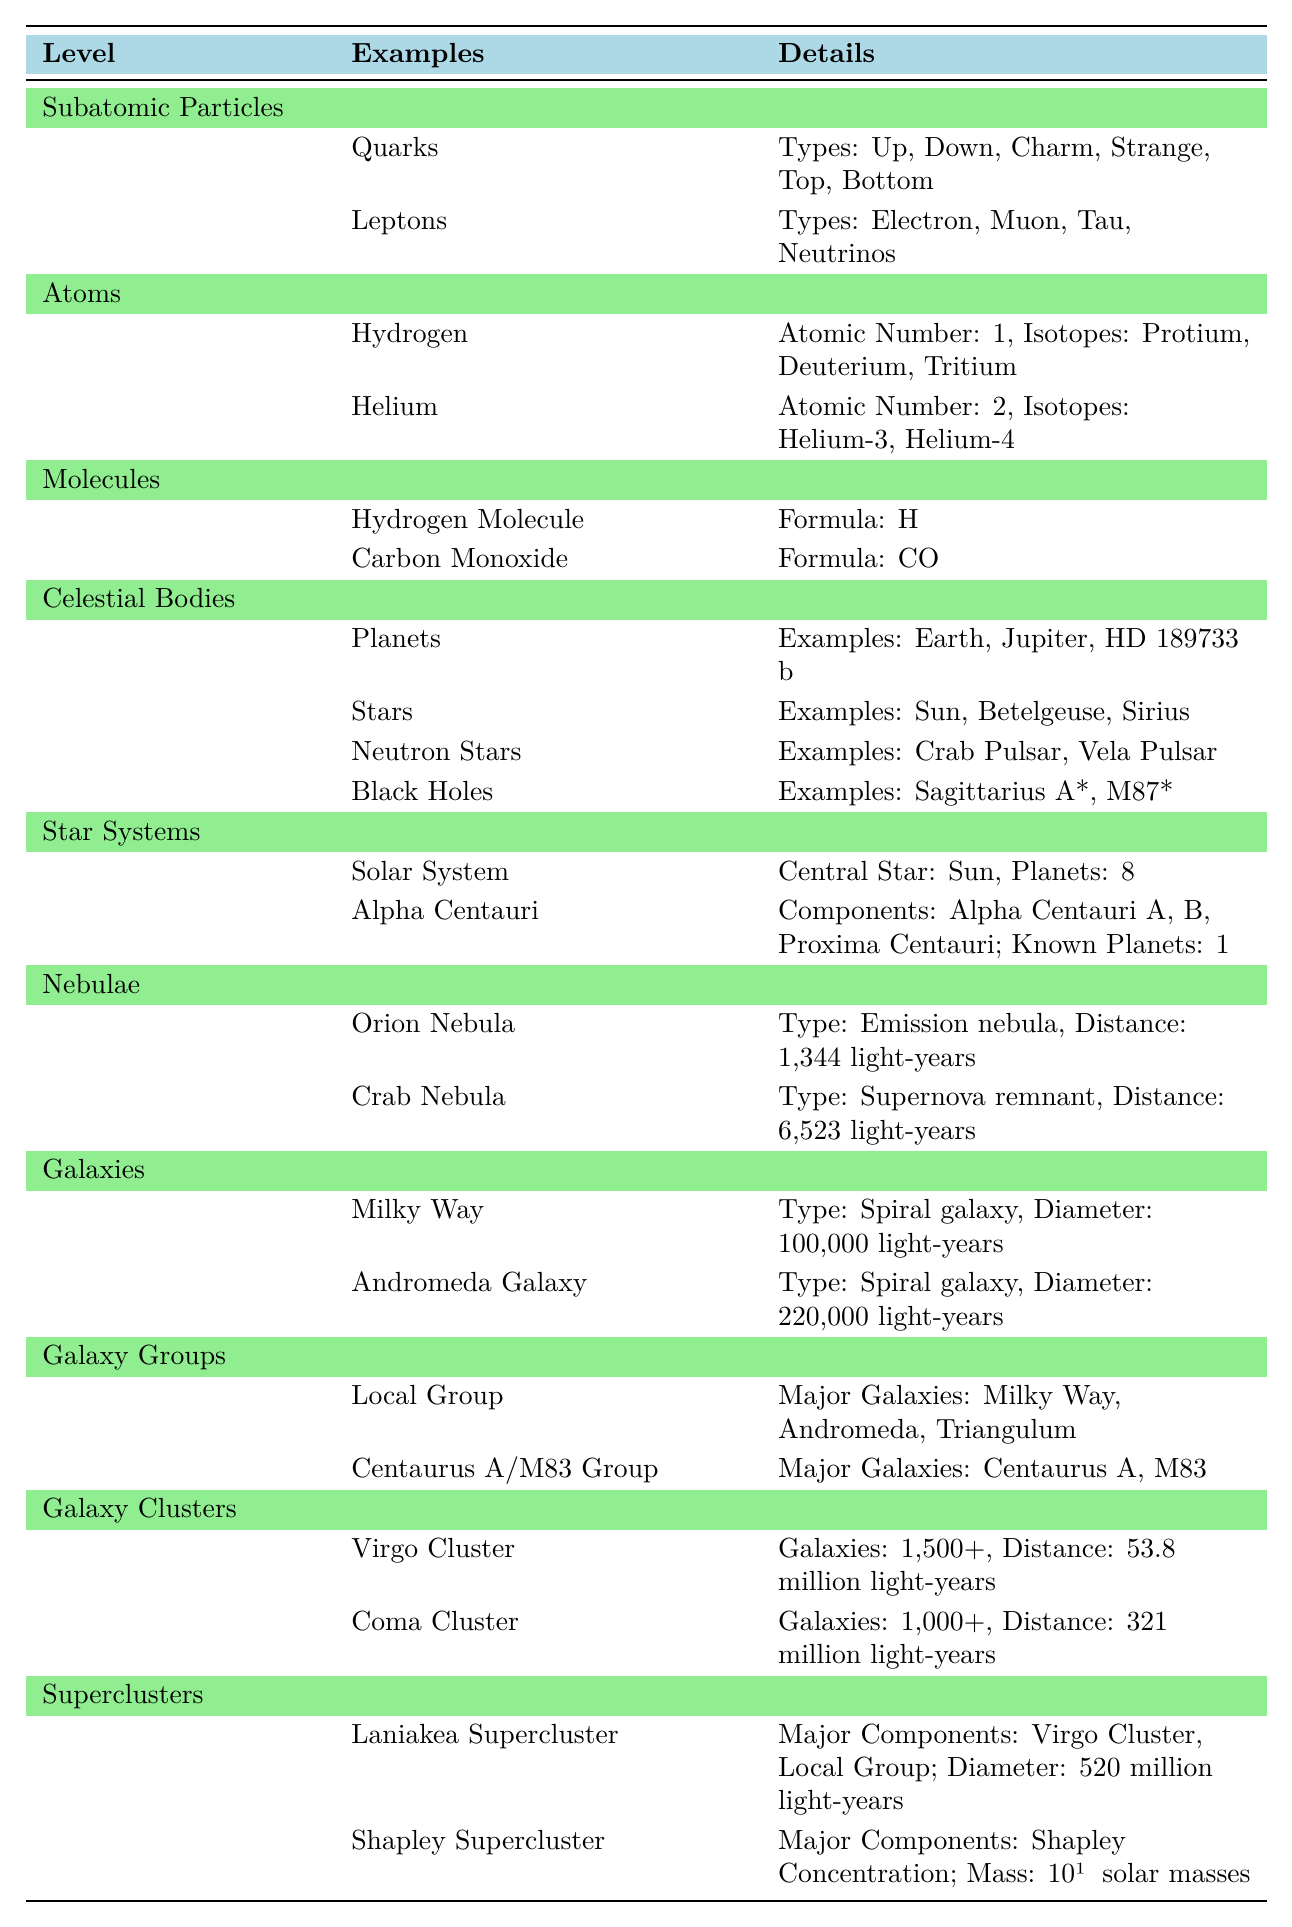What are the types of quarks listed in the table? The table provides information under the "Subatomic Particles" section, specifically mentioning quarks. It lists six types: Up, Down, Charm, Strange, Top, and Bottom.
Answer: Up, Down, Charm, Strange, Top, Bottom How many planets are in the Solar System according to the table? Under the "Star Systems" section, the Solar System is mentioned with the detail indicating it has 8 planets.
Answer: 8 Which nebula is classified as a supernova remnant? The table lists two nebulae under the "Nebulae" section. The Crab Nebula is specifically categorized as a "Supernova remnant."
Answer: Crab Nebula What is the diameter of the Andromeda Galaxy? In the "Galaxies" section, the Andromeda Galaxy is described and its diameter is specified as 220,000 light-years.
Answer: 220,000 light-years How many major galaxies are listed for the Local Group? The "Galaxy Groups" section states that the Local Group contains three major galaxies: Milky Way, Andromeda, and Triangulum.
Answer: 3 Is the Milky Way classified as a spiral galaxy? The table indicates that the Milky Way is mentioned under the "Galaxies" section and is classified as a spiral galaxy, confirming the statement.
Answer: Yes What is the total mass of Shapley Supercluster, according to the table? The table specifies the Shapley Supercluster's mass as 10¹⁶ solar masses in the "Superclusters" section.
Answer: 10¹⁶ solar masses Which type of nebula is the Orion Nebula categorized under? Within the "Nebulae" section, the Orion Nebula is classified as an "Emission nebula," thus providing the answer directly.
Answer: Emission nebula What is the distance to the Crab Nebula? The distance to the Crab Nebula is specified in the "Nebulae" section of the table as 6,523 light-years.
Answer: 6,523 light-years Which has a greater diameter, the Milky Way or the Laniakea Supercluster? The Milky Way's diameter is 100,000 light-years, and the Laniakea Supercluster's diameter is listed as 520 million light-years. Comparing both values, the Laniakea Supercluster has a far greater diameter than the Milky Way.
Answer: Laniakea Supercluster How many planets are indicated for the Alpha Centauri system? The table provides the information under the "Star Systems" section, mentioning that there is 1 known planet in the Alpha Centauri system.
Answer: 1 Which galaxy group includes the Centaurus A and M83? The "Galaxy Groups" section of the table names the "Centaurus A/M83 Group," confirming the galaxies included in this group.
Answer: Centaurus A/M83 Group Which celestial bodies are classified as black holes in the table? Under the "Celestial Bodies" section, the black holes identified are Sagittarius A* and M87*, directly answering the question.
Answer: Sagittarius A*, M87* What is the distance of the Virgo Cluster? The "Galaxy Clusters" section states that the distance to the Virgo Cluster is 53.8 million light-years, which is the required information.
Answer: 53.8 million light-years List the isotopes of Hydrogen as per the table. The table states under the "Atoms" section that Hydrogen has three isotopes: Protium, Deuterium, and Tritium.
Answer: Protium, Deuterium, Tritium 